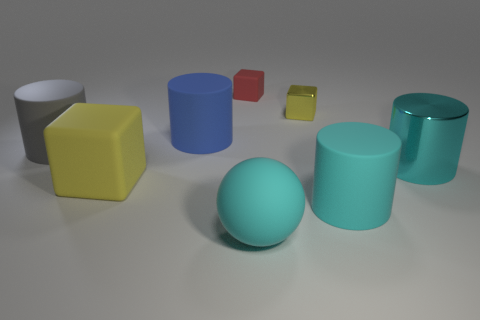Is the color of the large metallic object the same as the large matte object that is on the right side of the yellow metallic thing?
Offer a terse response. Yes. Are there the same number of large cylinders right of the tiny shiny object and red rubber cubes that are left of the gray object?
Provide a short and direct response. No. There is a yellow block in front of the small metal thing; what material is it?
Your response must be concise. Rubber. What number of objects are either small blocks that are in front of the tiny red matte object or tiny red matte things?
Your response must be concise. 2. How many other objects are there of the same shape as the small metal thing?
Your answer should be compact. 2. Do the yellow object left of the blue object and the blue rubber object have the same shape?
Offer a terse response. No. Are there any rubber things in front of the cyan metal thing?
Your answer should be very brief. Yes. How many tiny objects are metal cylinders or gray blocks?
Make the answer very short. 0. Do the red thing and the big block have the same material?
Offer a very short reply. Yes. There is a thing that is the same color as the large block; what size is it?
Ensure brevity in your answer.  Small. 